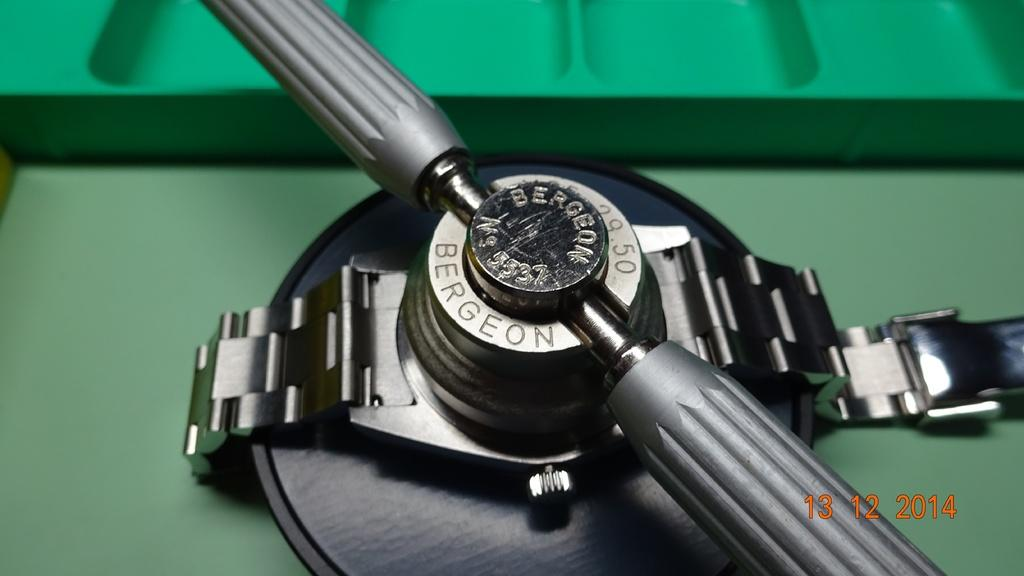<image>
Present a compact description of the photo's key features. A watch with a piece of equipment over it in a picture dated 13/12/14. 